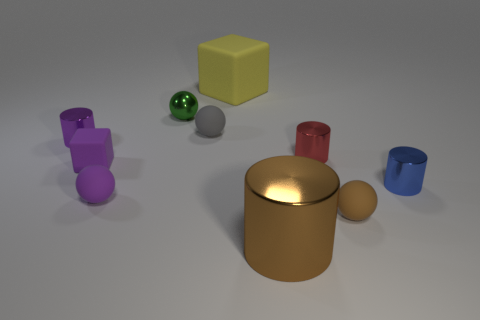The green shiny object is what shape?
Your answer should be very brief. Sphere. There is another thing that is the same size as the yellow thing; what is its shape?
Offer a very short reply. Cylinder. What number of other things are the same color as the large matte thing?
Your response must be concise. 0. Does the tiny matte object that is behind the tiny purple shiny thing have the same shape as the small matte thing that is on the right side of the big brown thing?
Offer a terse response. Yes. What number of things are small metallic things that are in front of the metallic sphere or rubber spheres to the right of the large yellow matte object?
Ensure brevity in your answer.  4. How many other things are the same material as the small cube?
Ensure brevity in your answer.  4. Is the ball that is on the right side of the brown metal thing made of the same material as the small block?
Offer a very short reply. Yes. Is the number of tiny blue objects that are right of the tiny blue metallic thing greater than the number of red metallic objects that are in front of the brown matte object?
Offer a terse response. No. How many objects are tiny balls that are in front of the small purple shiny object or brown metal things?
Your answer should be very brief. 3. There is a purple object that is made of the same material as the big cylinder; what shape is it?
Your answer should be very brief. Cylinder. 